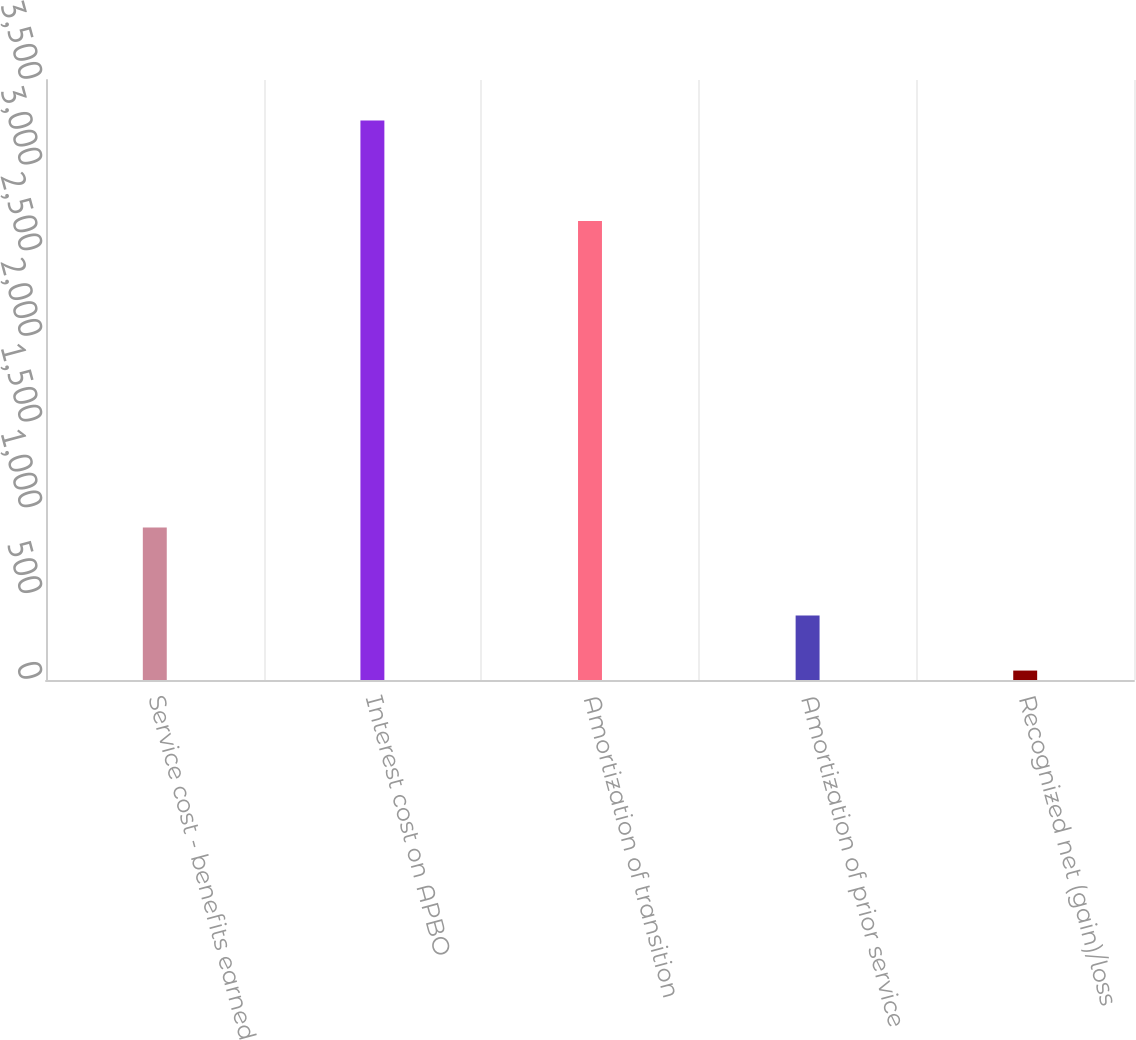Convert chart. <chart><loc_0><loc_0><loc_500><loc_500><bar_chart><fcel>Service cost - benefits earned<fcel>Interest cost on APBO<fcel>Amortization of transition<fcel>Amortization of prior service<fcel>Recognized net (gain)/loss<nl><fcel>889<fcel>3264<fcel>2678<fcel>375.9<fcel>55<nl></chart> 